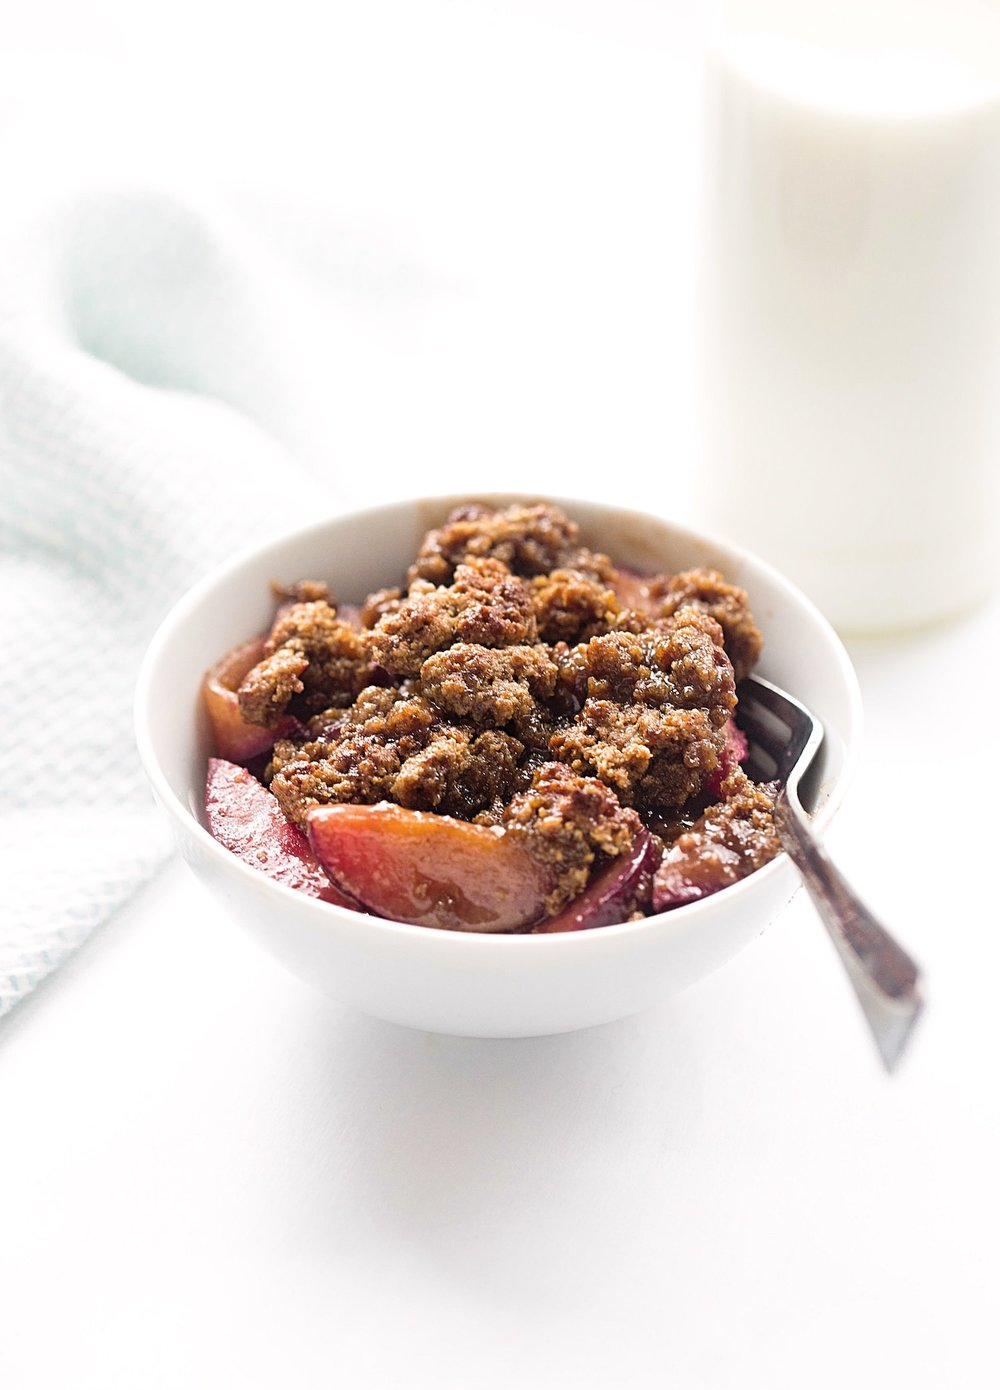Considering the setup of the dessert and the glass of milk, for what type of meal or occasion might this food be typically served? The dessert, which resembles a fruit crumble, paired with a glass of milk suggests a comforting and homey meal, often associated with a casual dining experience. This setup could be indicative of a family dessert after dinner, a special treat during a weekend brunch, or a cozy afternoon snack. The presence of the milk also implies that it could be intended for a younger audience or for those who enjoy a classic combination of a warm dessert with cold milk. The simplicity and familiarity of the dish do not necessarily point to a formal occasion but rather to everyday family meals or casual gatherings. 